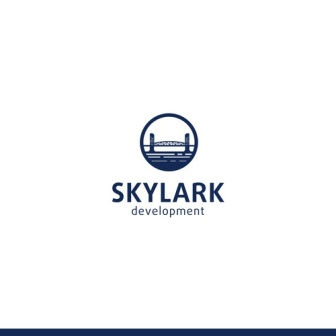If this logo were to come to life as a real scene, what would it look like? Imagine stepping into a bustling, modern city with sleek skyscrapers towering overhead, their glass facades reflecting the sunlight in brilliant hues of blue. Walking across a grand bridge, you see the skyline stretching out before you, a testament to innovation and architectural prowess. The streets are lively with people and vehicles, yet there's a sense of harmony and order, reflective of the structured environment symbolized by the logo. 